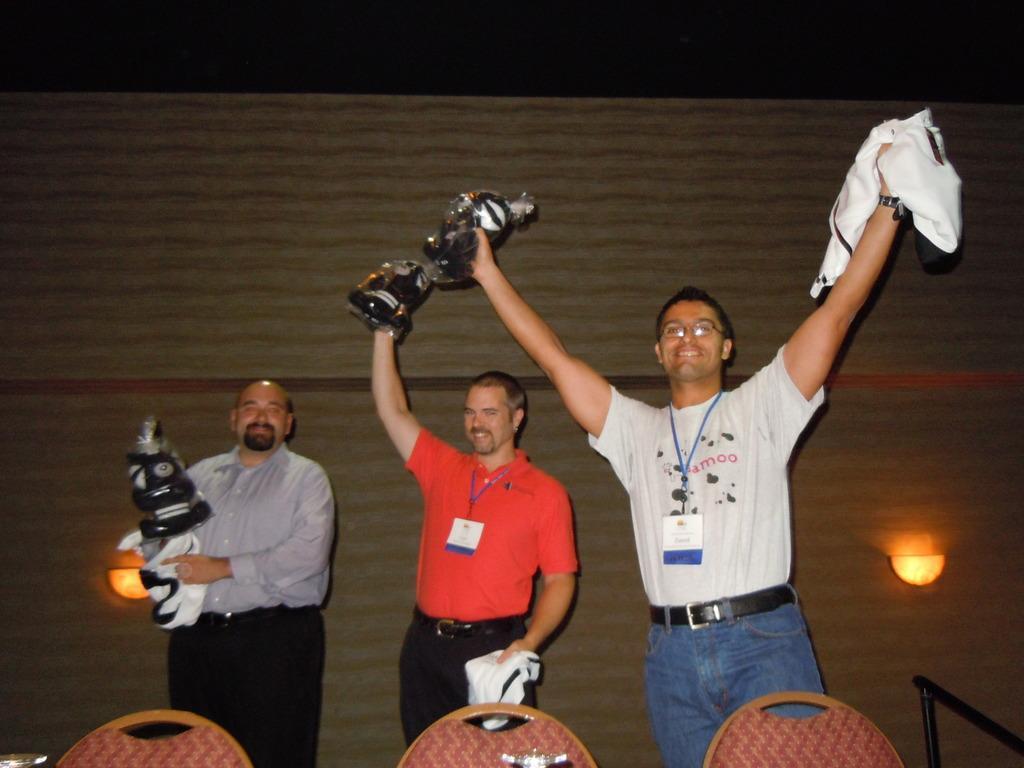In one or two sentences, can you explain what this image depicts? In this image I can see three persons standing and they are holding few objects. In front I can see three chairs. In the background I can see few lights. 